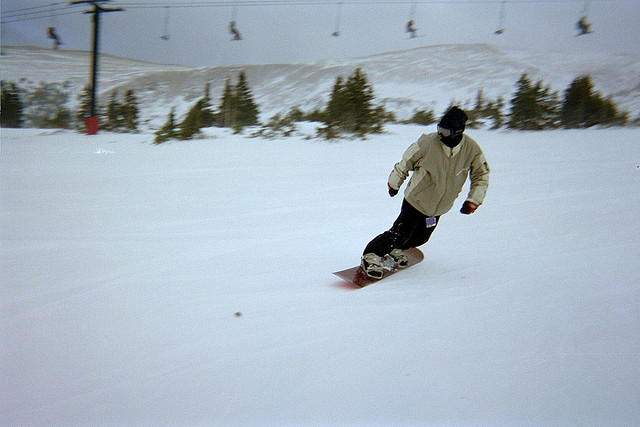<image>What trick is the man doing? I don't know what trick the man is doing. It could be snowboarding, a backwards slide or sliding sideways. What trick is the man doing? I don't know what trick the man is doing. It can be snowboarding or a backwards slide. 